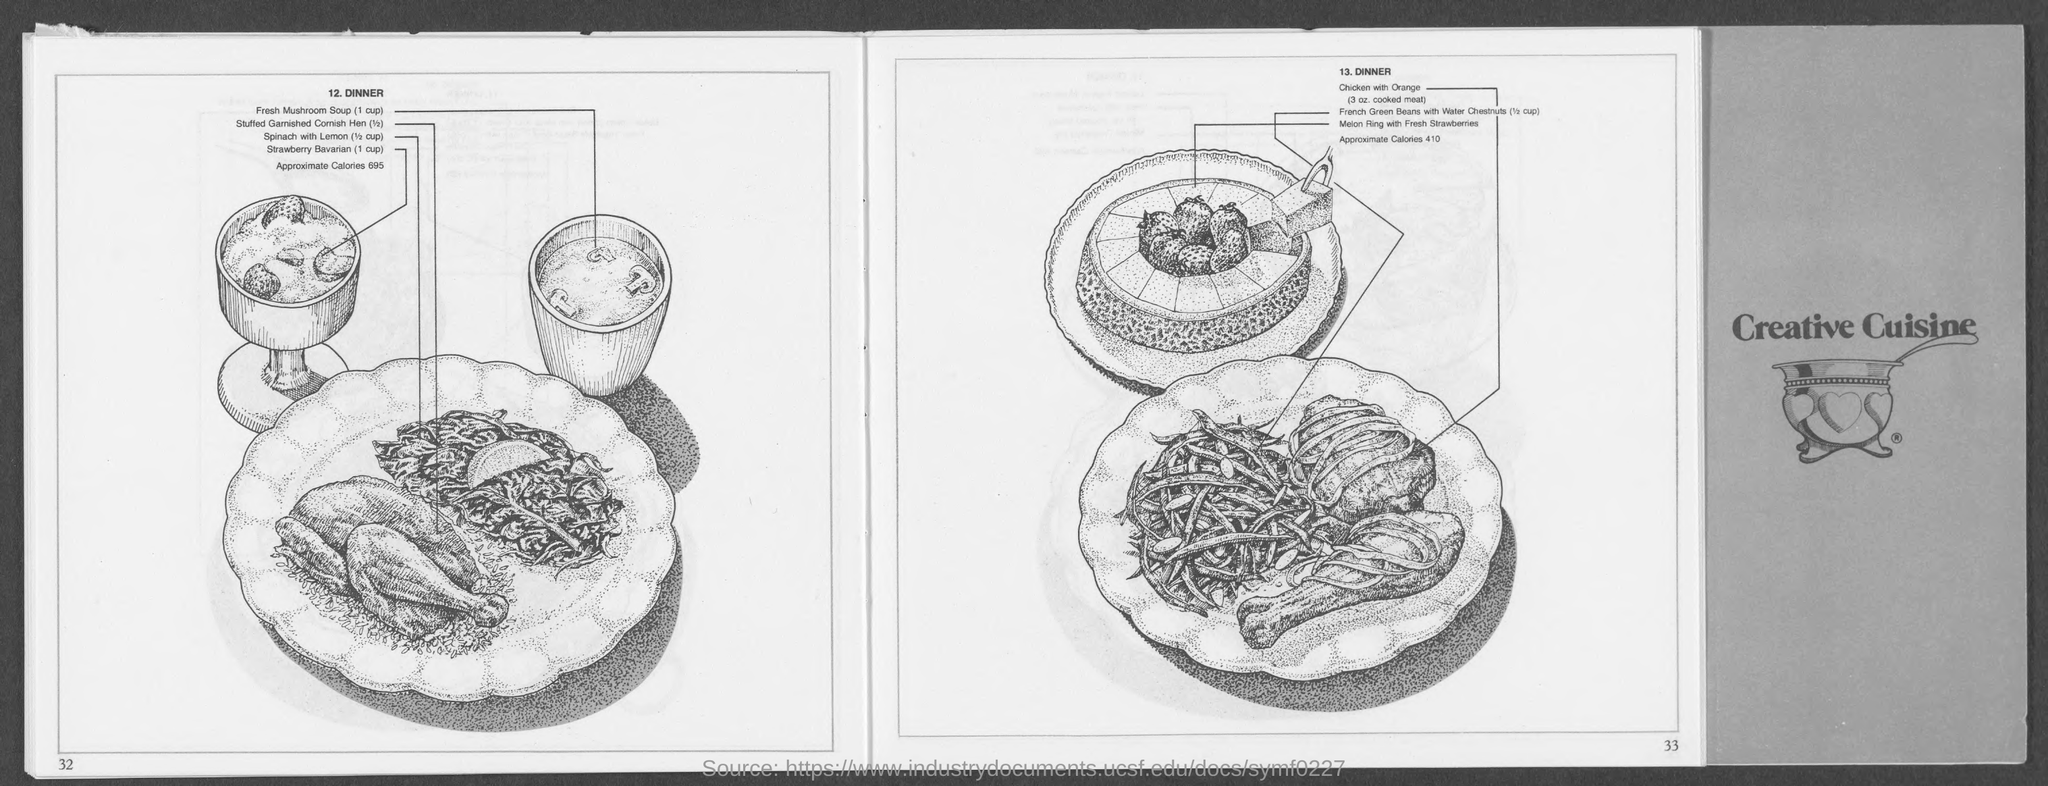Point out several critical features in this image. The approximate caloric value of dinner, as listed in point number 13, is 410. The book cover bears the name 'Creative Cuisine,' which is the title of the book. Under item 13, the amount of chicken with orange is 3. The approximate caloric value of dinner under point number 12 is 695. 